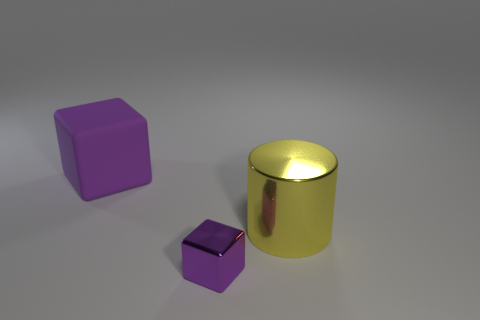Is the color of the metal cube the same as the large rubber cube? yes 